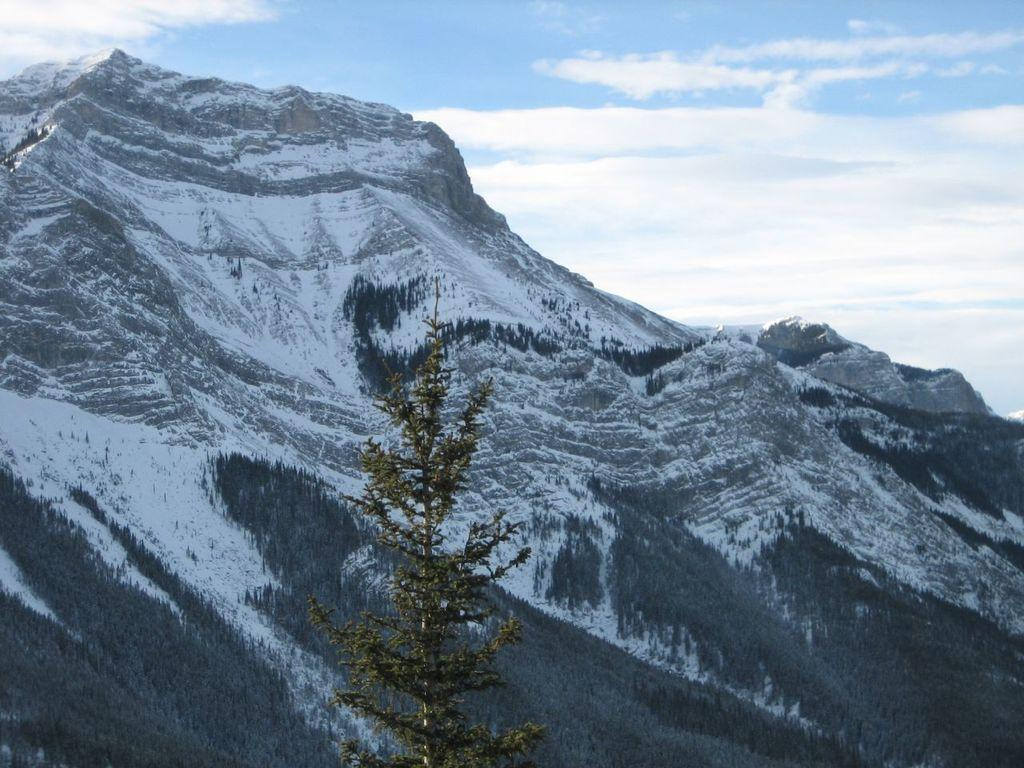What is the main subject in the center of the image? There is a tree in the center of the image. What can be seen in the background of the image? There is a snow mountain and the sky visible in the background of the image. What type of roll is being used to climb the snow mountain in the image? There is no roll or climbing activity present in the image; it simply shows a tree and a snow mountain in the background. 